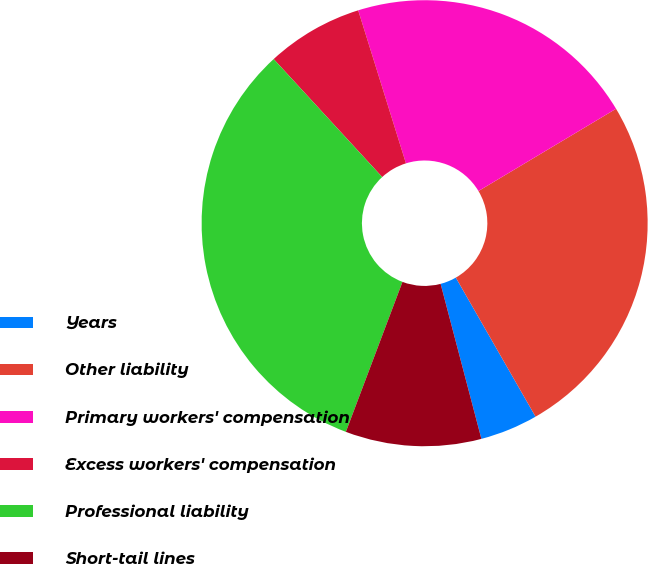Convert chart. <chart><loc_0><loc_0><loc_500><loc_500><pie_chart><fcel>Years<fcel>Other liability<fcel>Primary workers' compensation<fcel>Excess workers' compensation<fcel>Professional liability<fcel>Short-tail lines<nl><fcel>4.19%<fcel>25.29%<fcel>21.24%<fcel>7.02%<fcel>32.42%<fcel>9.84%<nl></chart> 